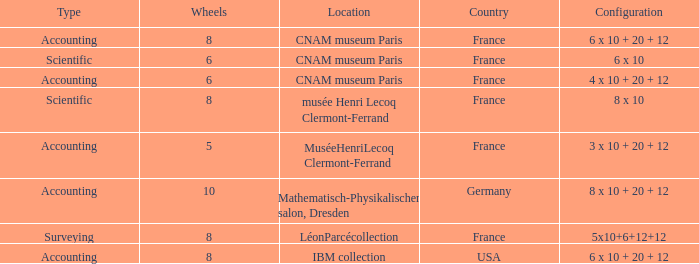What average wheels has accounting as the type, with IBM Collection as the location? 8.0. 